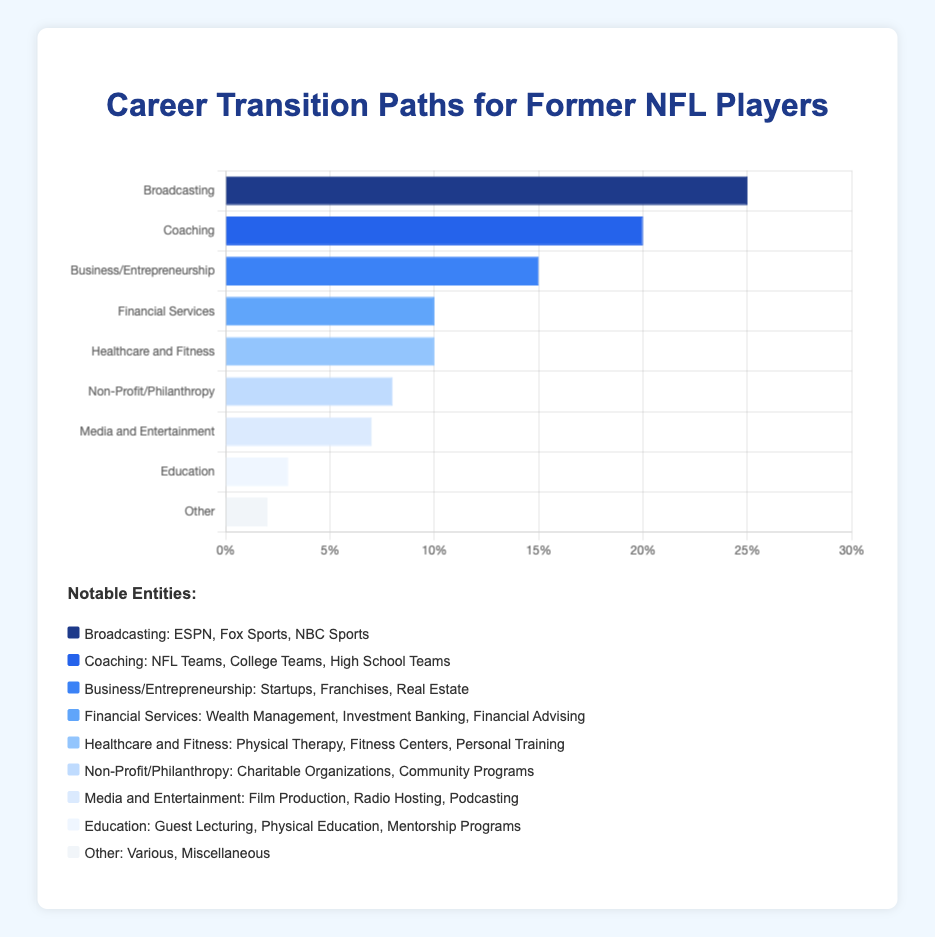What is the industry with the highest percentage of former NFL players transitioning into it? To determine the industry with the highest percentage, refer to the bar that extends the farthest to the right on the horizontal bar chart. Broadcasting is the longest and has a percentage value of 25%.
Answer: Broadcasting Which industry do the second most number of former NFL players transition into? The second most popular industry will be the bar that is second longest after Broadcasting. Coaching has the second longest bar, with a percentage value of 20%.
Answer: Coaching What is the combined percentage of former NFL players that transition into Business/Entrepreneurship and Financial Services? To find the combined percentage, sum the percentages for Business/Entrepreneurship and Financial Services. Business/Entrepreneurship is at 15% and Financial Services is at 10%, so 15% + 10% = 25%.
Answer: 25% How much smaller is the percentage of former NFL players that transition into Education compared to Business/Entrepreneurship? Subtract the percentage for Education from the percentage for Business/Entrepreneurship. Business/Entrepreneurship has 15% and Education has 3%, so 15% - 3% = 12%.
Answer: 12% Which industries have the same percentage of former NFL players transitioning into them? Look for bars that are of equal length. Financial Services and Healthcare and Fitness both have bars that extend to 10%.
Answer: Financial Services and Healthcare and Fitness What is the average percentage of former NFL players transitioning into Non-Profit/Philanthropy, Media and Entertainment, and Education? To find the average, add the percentages for these three industries and divide by the number of industries. Non-Profit/Philanthropy is at 8%, Media and Entertainment is at 7%, and Education is at 3%. (8% + 7% + 3%) / 3 = 18% / 3 = 6%.
Answer: 6% How many percentage points more do former NFL players transition into Healthcare and Fitness than into Media and Entertainment? Subtract the Media and Entertainment percentage from the Healthcare and Fitness percentage. Healthcare and Fitness is 10%, and Media and Entertainment is 7%, so 10% - 7% = 3%.
Answer: 3 What is the total percentage of former NFL players that transition into Coaching, Financial Services, and Other combined? Add the percentages for these three industries. Coaching is 20%, Financial Services is 10%, and Other is 2%. 20% + 10% + 2% = 32%.
Answer: 32% Which industry associated with "startups, franchises, and real estate" do former NFL players transition into? Refer to the notable entities associated with each industry listed in the chart legend. The industry with "startups, franchises, and real estate" is Business/Entrepreneurship.
Answer: Business/Entrepreneurship 